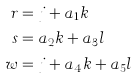<formula> <loc_0><loc_0><loc_500><loc_500>r & = j + a _ { 1 } k \\ s & = a _ { 2 } k + a _ { 3 } l \\ w & = j + a _ { 4 } k + a _ { 5 } l</formula> 